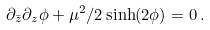<formula> <loc_0><loc_0><loc_500><loc_500>\partial _ { \bar { z } } \partial _ { z } \phi + \mu ^ { 2 } / 2 \sinh ( 2 \phi ) = 0 \, .</formula> 